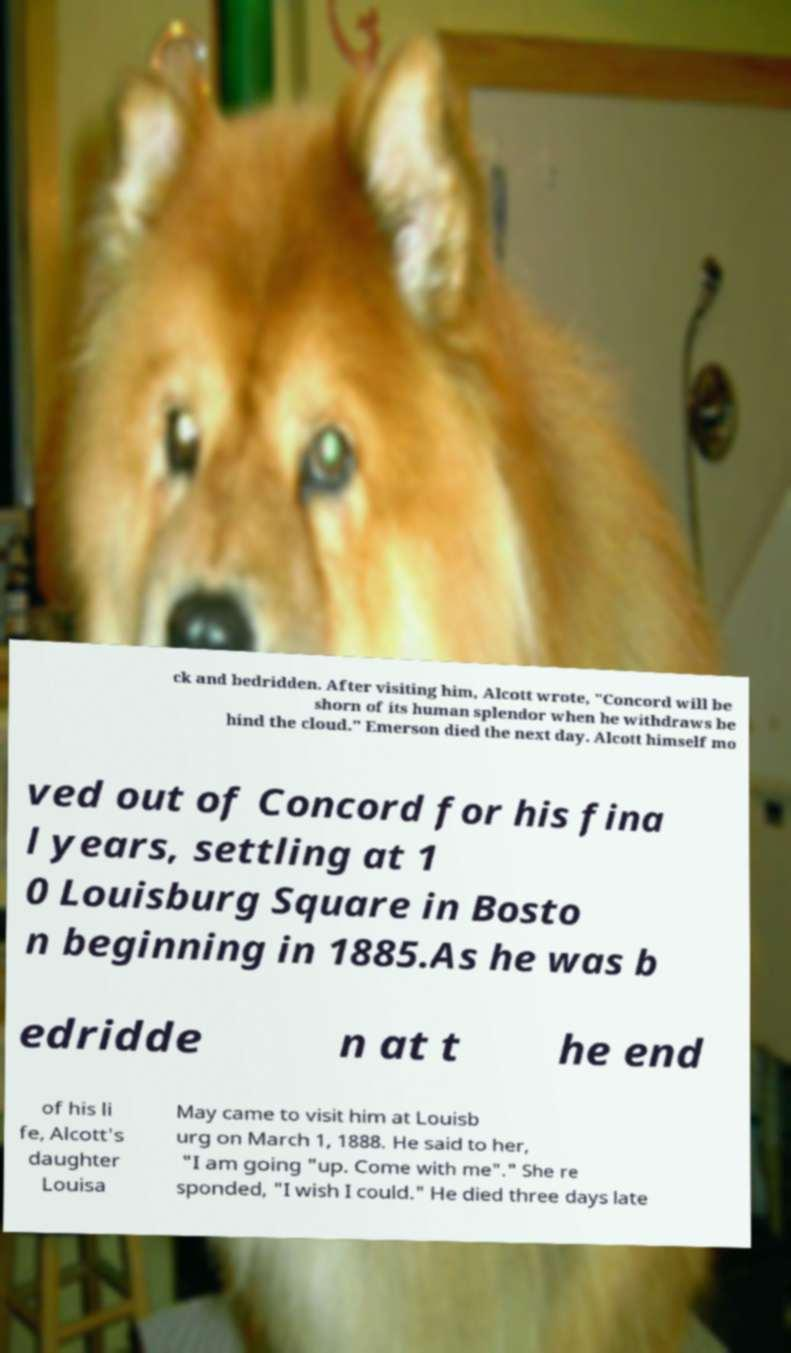Please read and relay the text visible in this image. What does it say? ck and bedridden. After visiting him, Alcott wrote, "Concord will be shorn of its human splendor when he withdraws be hind the cloud." Emerson died the next day. Alcott himself mo ved out of Concord for his fina l years, settling at 1 0 Louisburg Square in Bosto n beginning in 1885.As he was b edridde n at t he end of his li fe, Alcott's daughter Louisa May came to visit him at Louisb urg on March 1, 1888. He said to her, "I am going "up. Come with me"." She re sponded, "I wish I could." He died three days late 